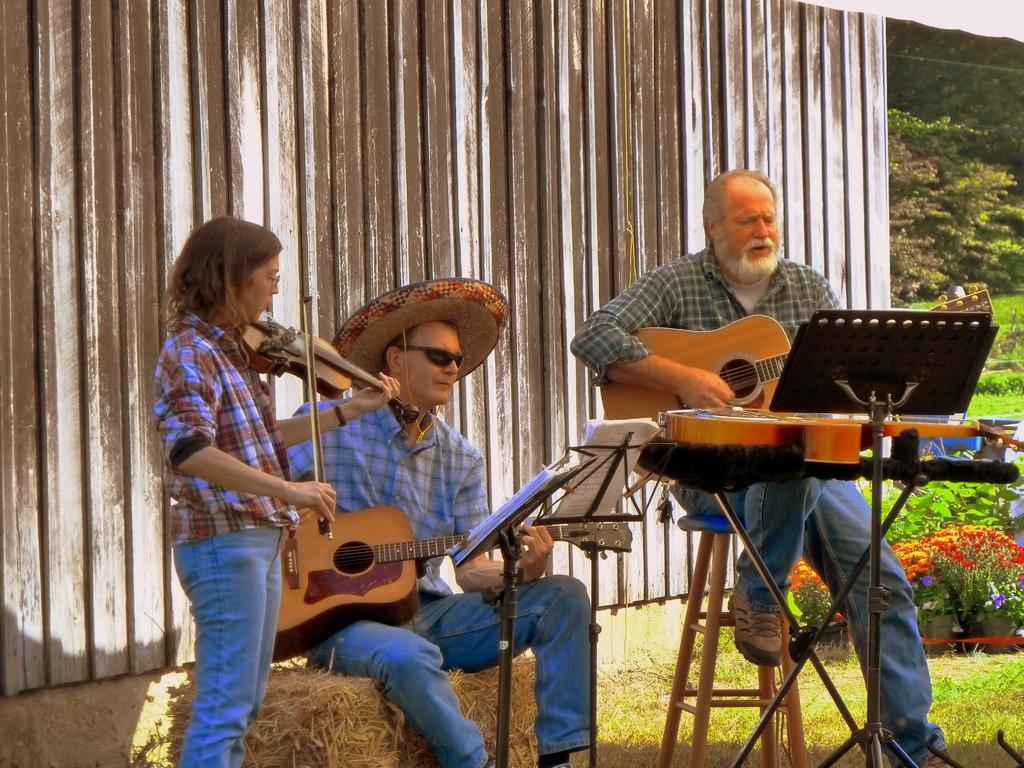How would you summarize this image in a sentence or two? In this image there are two man and a woman,the man are holding the guitar and playing,the woman is playing the musical instrument,at the background i can see a shed and a tree. 